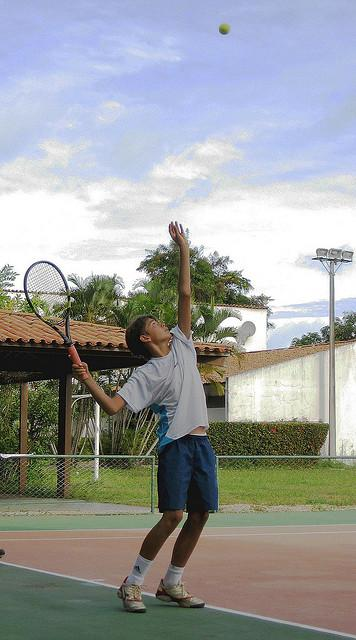Why is he standing like that? serving 